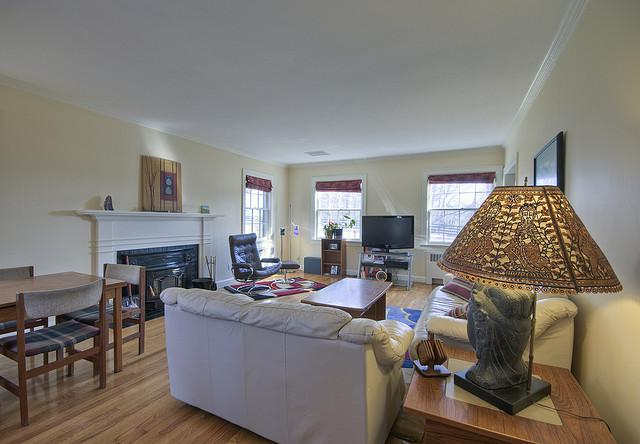What color are the sofa seats surrounding the table on the rug? white 